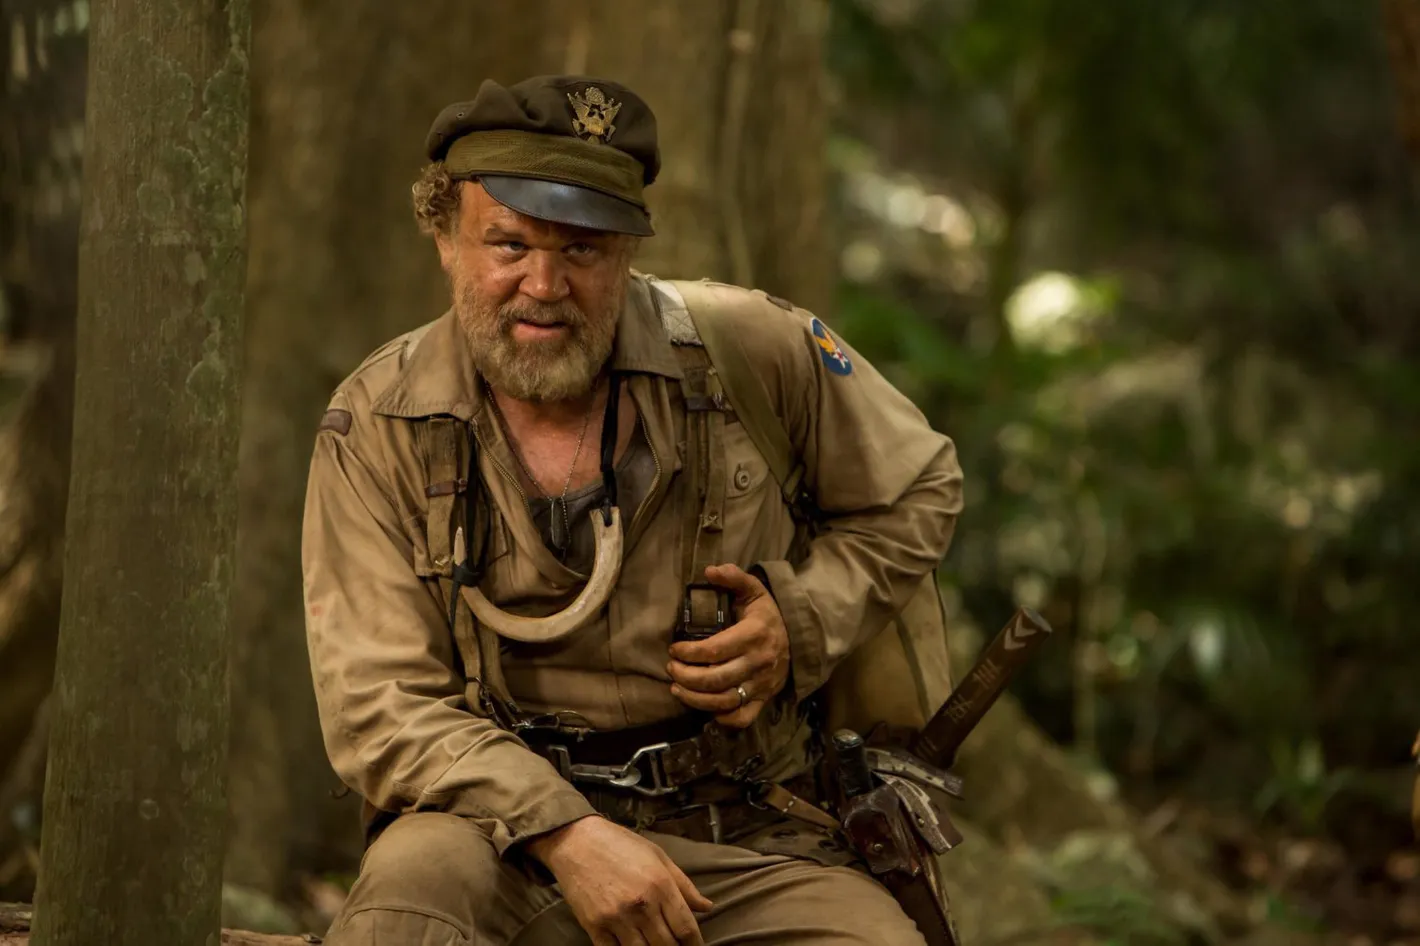What is the character's background story? The character appears to be a veteran soldier who has spent a significant amount of time in the wilderness. His rugged and weathered appearance suggests he has faced many hardships and battles. The khaki uniform, adorned with various badges and insignia, indicates his long service in the military. The machete in his grip and the serious expression on his face reflect a man who is always ready for danger and has learned to survive in extreme conditions. His deep contemplation might indicate a man haunted by his past experiences, living in isolation in the jungle as he grapples with personal demons and memories of war. 